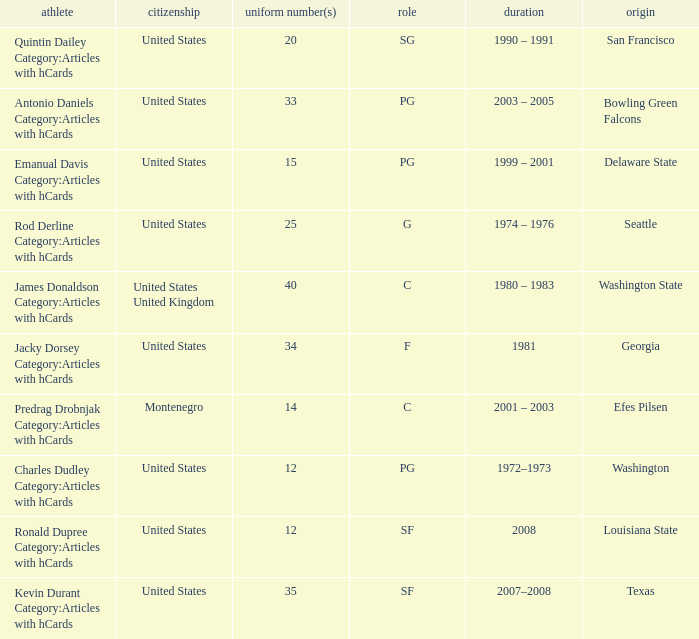What college was the player with the jersey number of 34 from? Georgia. 